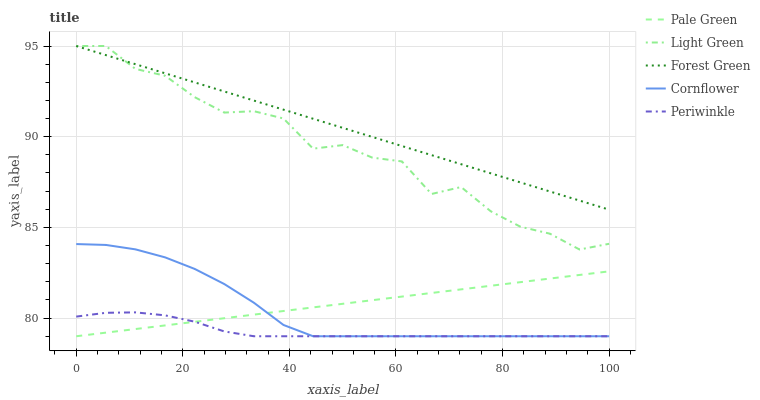Does Periwinkle have the minimum area under the curve?
Answer yes or no. Yes. Does Forest Green have the maximum area under the curve?
Answer yes or no. Yes. Does Pale Green have the minimum area under the curve?
Answer yes or no. No. Does Pale Green have the maximum area under the curve?
Answer yes or no. No. Is Pale Green the smoothest?
Answer yes or no. Yes. Is Light Green the roughest?
Answer yes or no. Yes. Is Forest Green the smoothest?
Answer yes or no. No. Is Forest Green the roughest?
Answer yes or no. No. Does Forest Green have the lowest value?
Answer yes or no. No. Does Pale Green have the highest value?
Answer yes or no. No. Is Pale Green less than Forest Green?
Answer yes or no. Yes. Is Light Green greater than Cornflower?
Answer yes or no. Yes. Does Pale Green intersect Forest Green?
Answer yes or no. No. 